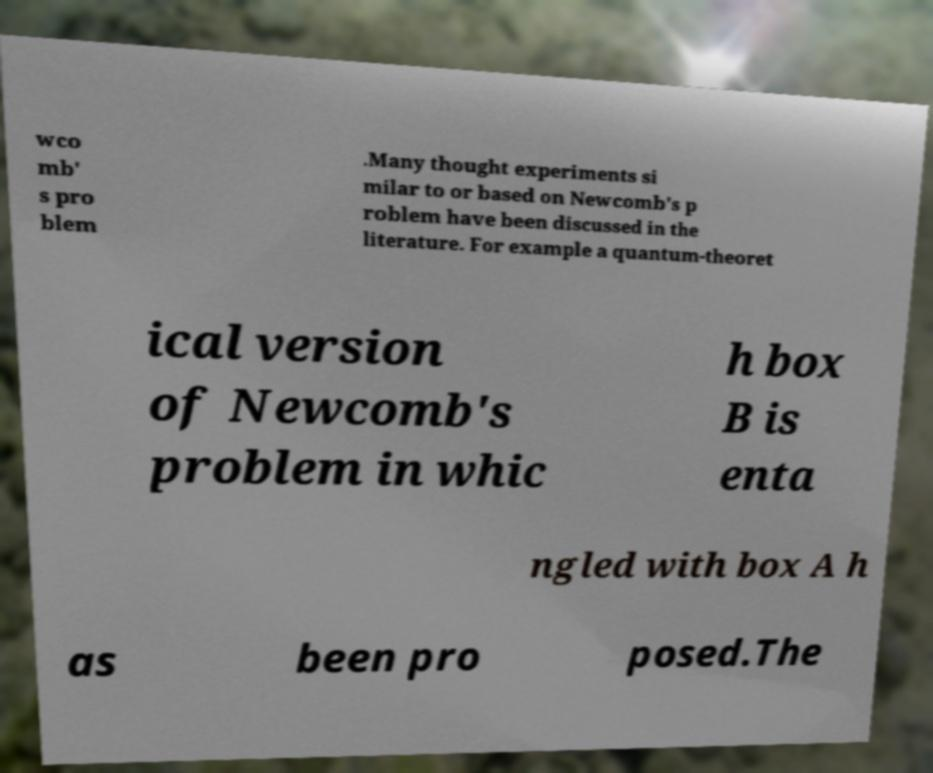There's text embedded in this image that I need extracted. Can you transcribe it verbatim? wco mb' s pro blem .Many thought experiments si milar to or based on Newcomb's p roblem have been discussed in the literature. For example a quantum-theoret ical version of Newcomb's problem in whic h box B is enta ngled with box A h as been pro posed.The 